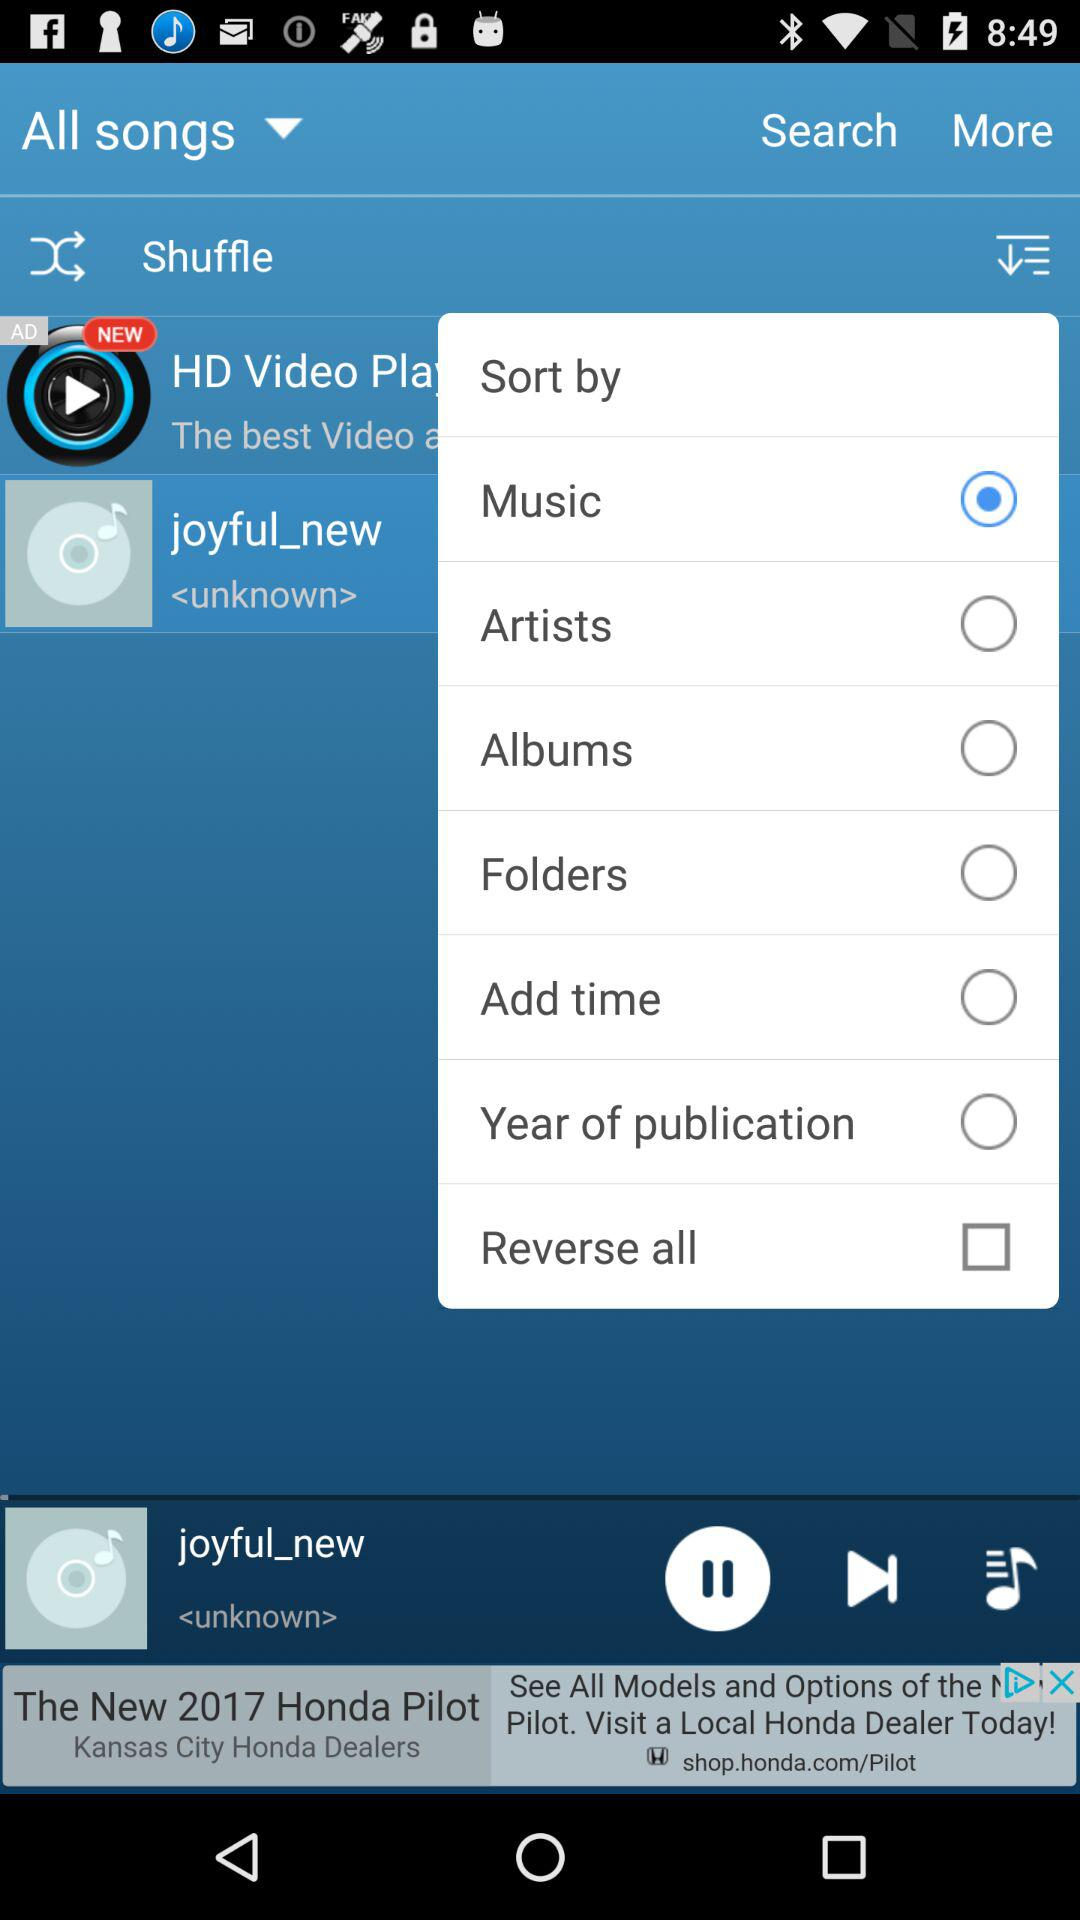What is the selected option? The selected option is "Music". 